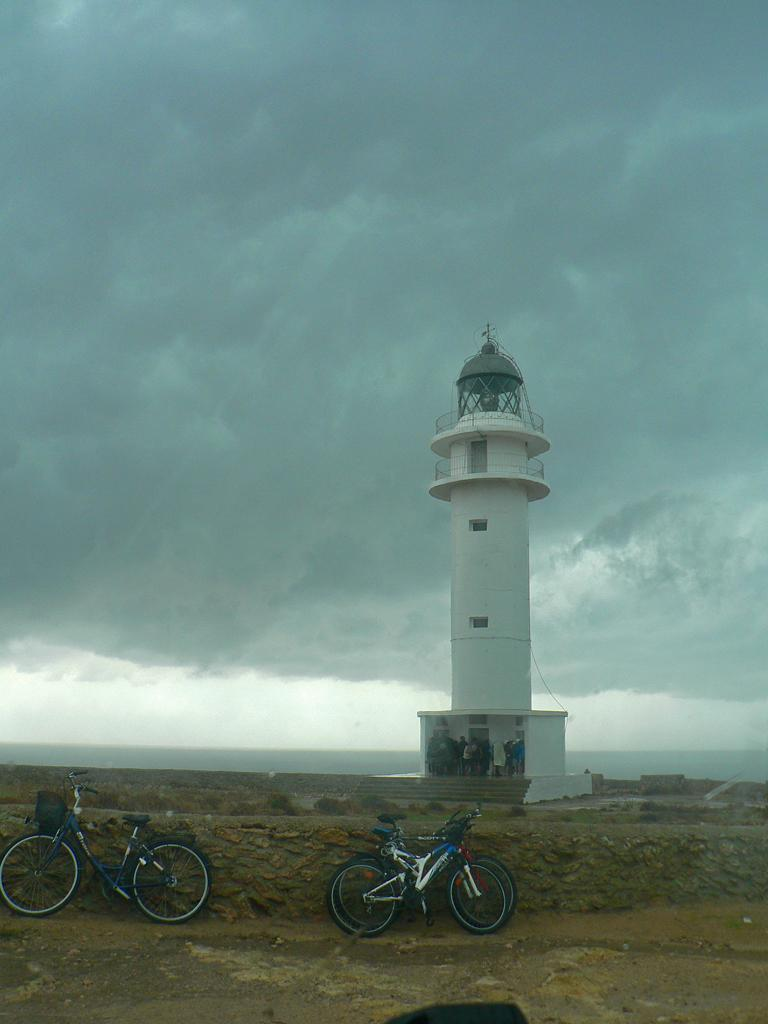What structure is located on the right side of the image? There is a tower on the right side of the image. What can be seen at the bottom side of the image? There are bicycles at the bottom side of the image. What is visible at the top side of the image? The sky is visible at the top side of the image. Where is the mother standing in the image? There is no mother present in the image. What type of vessel is being used in the meeting in the image? There is no vessel or meeting present in the image. 